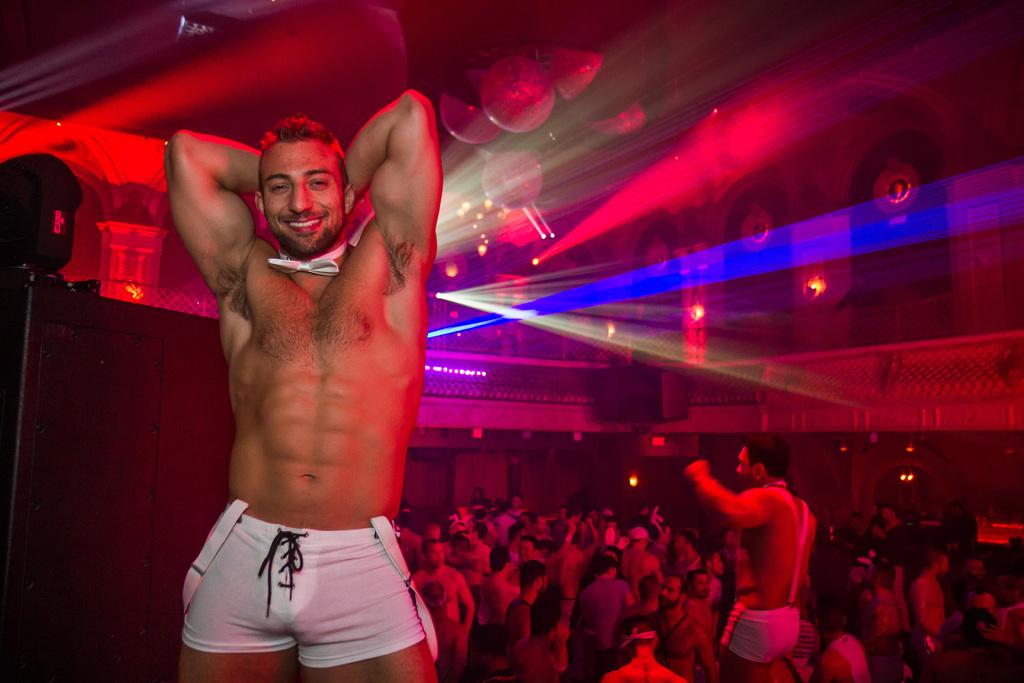Who is present in the image? There is a man in the image. What is the man doing in the image? The man is smiling in the image. What can be seen in the background of the image? There is a group of people, lights, and objects visible in the background of the image. What type of leaf is being used as an umbrella in the image? There is no leaf or umbrella present in the image. How does the man's hearing affect the group of people in the image? The man's hearing is not mentioned in the image, so it cannot be determined how it affects the group of people. 